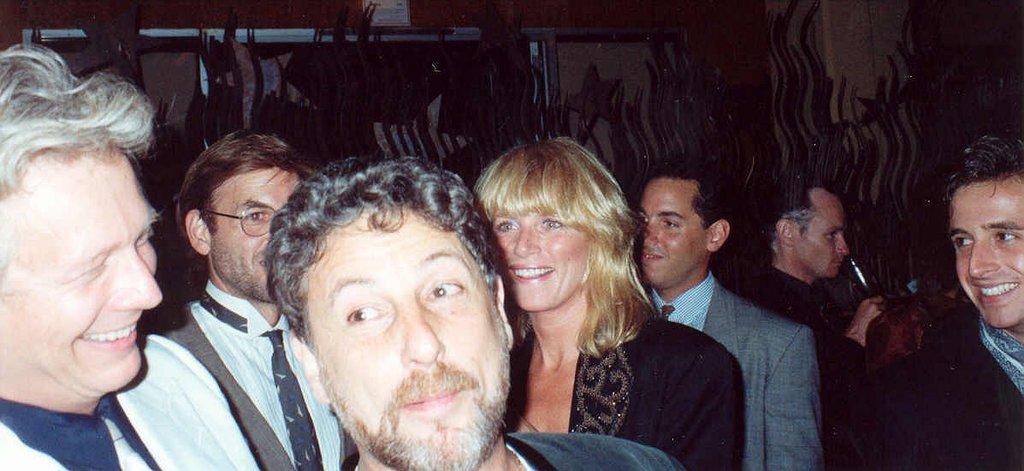Please provide a concise description of this image. In this picture there are people in the center of the image and the background area of the image is not clear. 